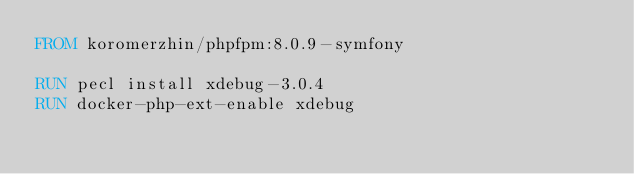<code> <loc_0><loc_0><loc_500><loc_500><_Dockerfile_>FROM koromerzhin/phpfpm:8.0.9-symfony

RUN pecl install xdebug-3.0.4
RUN docker-php-ext-enable xdebug</code> 